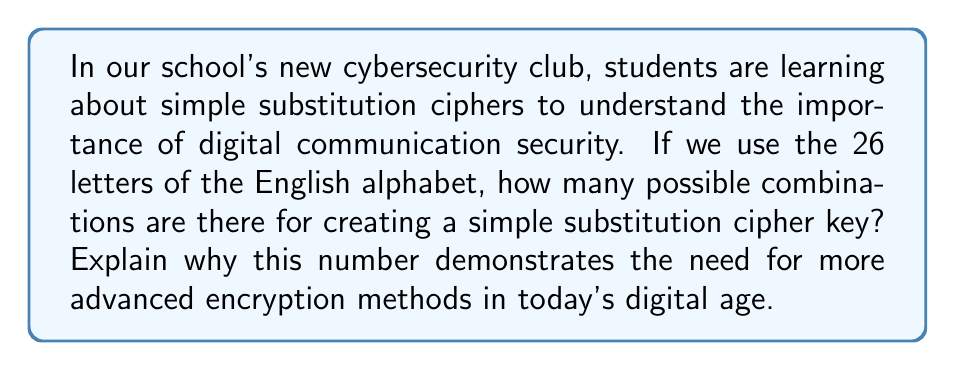Show me your answer to this math problem. Let's approach this step-by-step:

1) In a simple substitution cipher, each letter of the alphabet is replaced by another letter, and this replacement is consistent throughout the message.

2) For the first letter of the cipher alphabet, we have 26 choices from the original alphabet.

3) For the second letter, we have 25 choices, as we can't use the letter we used for the first position.

4) For the third letter, we have 24 choices, and so on.

5) This continues until we assign the last letter, where we have only 1 choice left.

6) Mathematically, this is represented by the factorial of 26, written as 26!

7) The calculation is:

   $$26! = 26 \times 25 \times 24 \times 23 \times ... \times 3 \times 2 \times 1$$

8) This equals:

   $$26! = 403,291,461,126,605,635,584,000,000$$

9) This extremely large number demonstrates why simple substitution ciphers are not secure for modern digital communication. While it would take an impossibly long time to try all combinations by hand, computers can break these ciphers quickly using frequency analysis and other techniques.

10) This reinforces the need for more advanced encryption methods in our digital age, highlighting the importance of teaching students about cybersecurity in today's interconnected world.
Answer: $26! = 403,291,461,126,605,635,584,000,000$ 